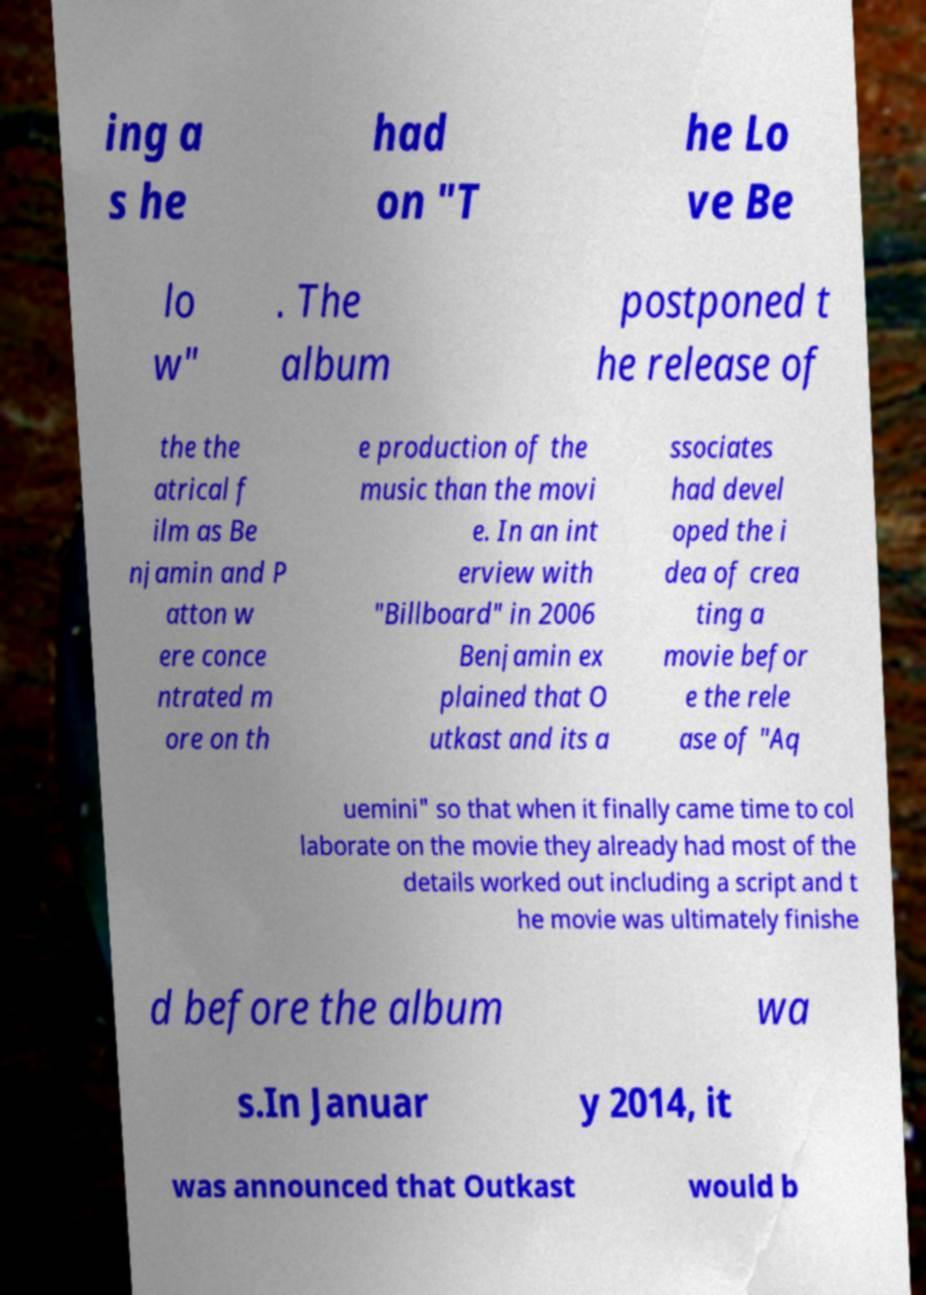For documentation purposes, I need the text within this image transcribed. Could you provide that? ing a s he had on "T he Lo ve Be lo w" . The album postponed t he release of the the atrical f ilm as Be njamin and P atton w ere conce ntrated m ore on th e production of the music than the movi e. In an int erview with "Billboard" in 2006 Benjamin ex plained that O utkast and its a ssociates had devel oped the i dea of crea ting a movie befor e the rele ase of "Aq uemini" so that when it finally came time to col laborate on the movie they already had most of the details worked out including a script and t he movie was ultimately finishe d before the album wa s.In Januar y 2014, it was announced that Outkast would b 